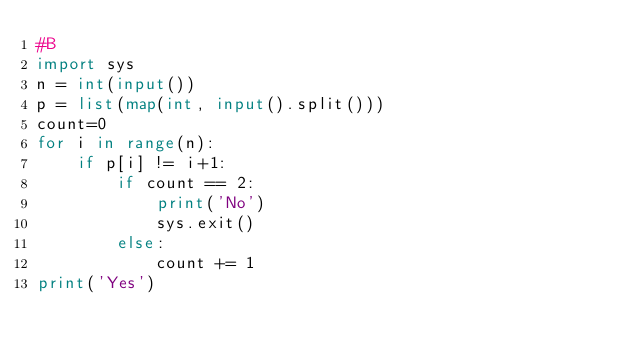Convert code to text. <code><loc_0><loc_0><loc_500><loc_500><_Python_>#B
import sys
n = int(input())
p = list(map(int, input().split()))
count=0
for i in range(n):
    if p[i] != i+1:
        if count == 2:
            print('No')
            sys.exit()
        else:
            count += 1
print('Yes')</code> 